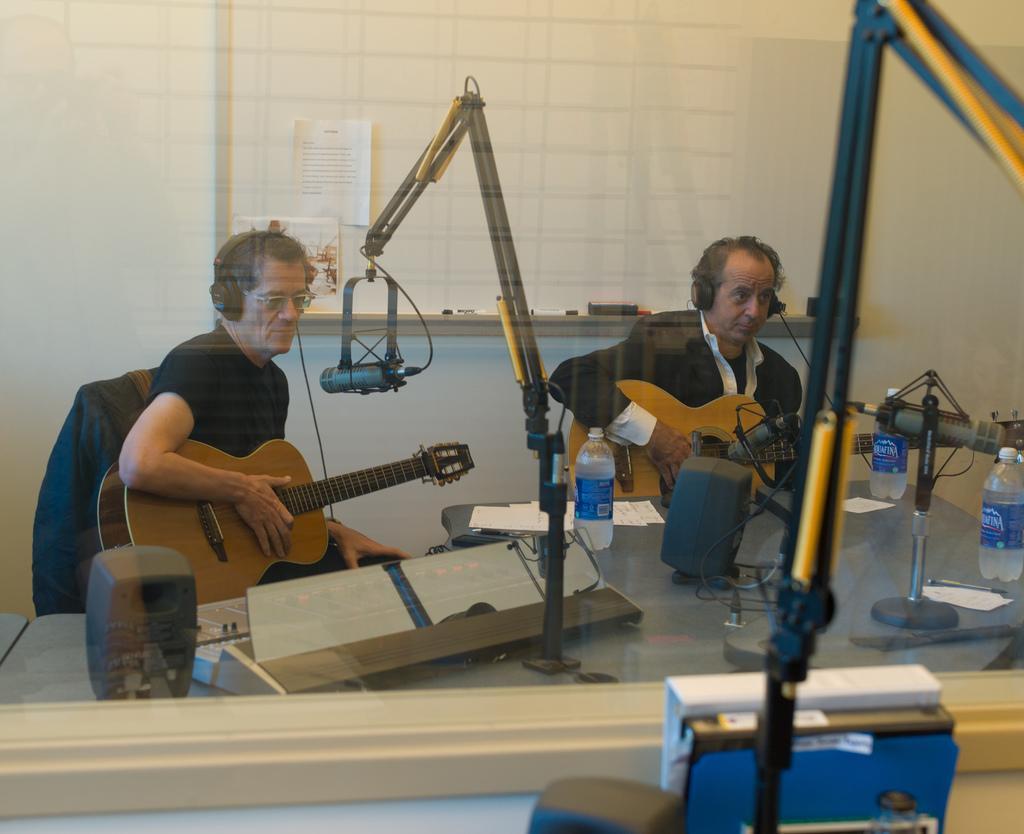How would you summarize this image in a sentence or two? In this picture we can see 2 men who are sitting on chairs and they are having guitars, they also wear headsets. In front of them there are microphones. It seems like they are singing. In front of them there is a table on which we can see loudspeakers, water bottles, some musical instruments. It seems like musical concert. 